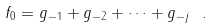<formula> <loc_0><loc_0><loc_500><loc_500>f _ { 0 } = g _ { - 1 } + g _ { - 2 } + \cdots + g _ { - j } \ .</formula> 